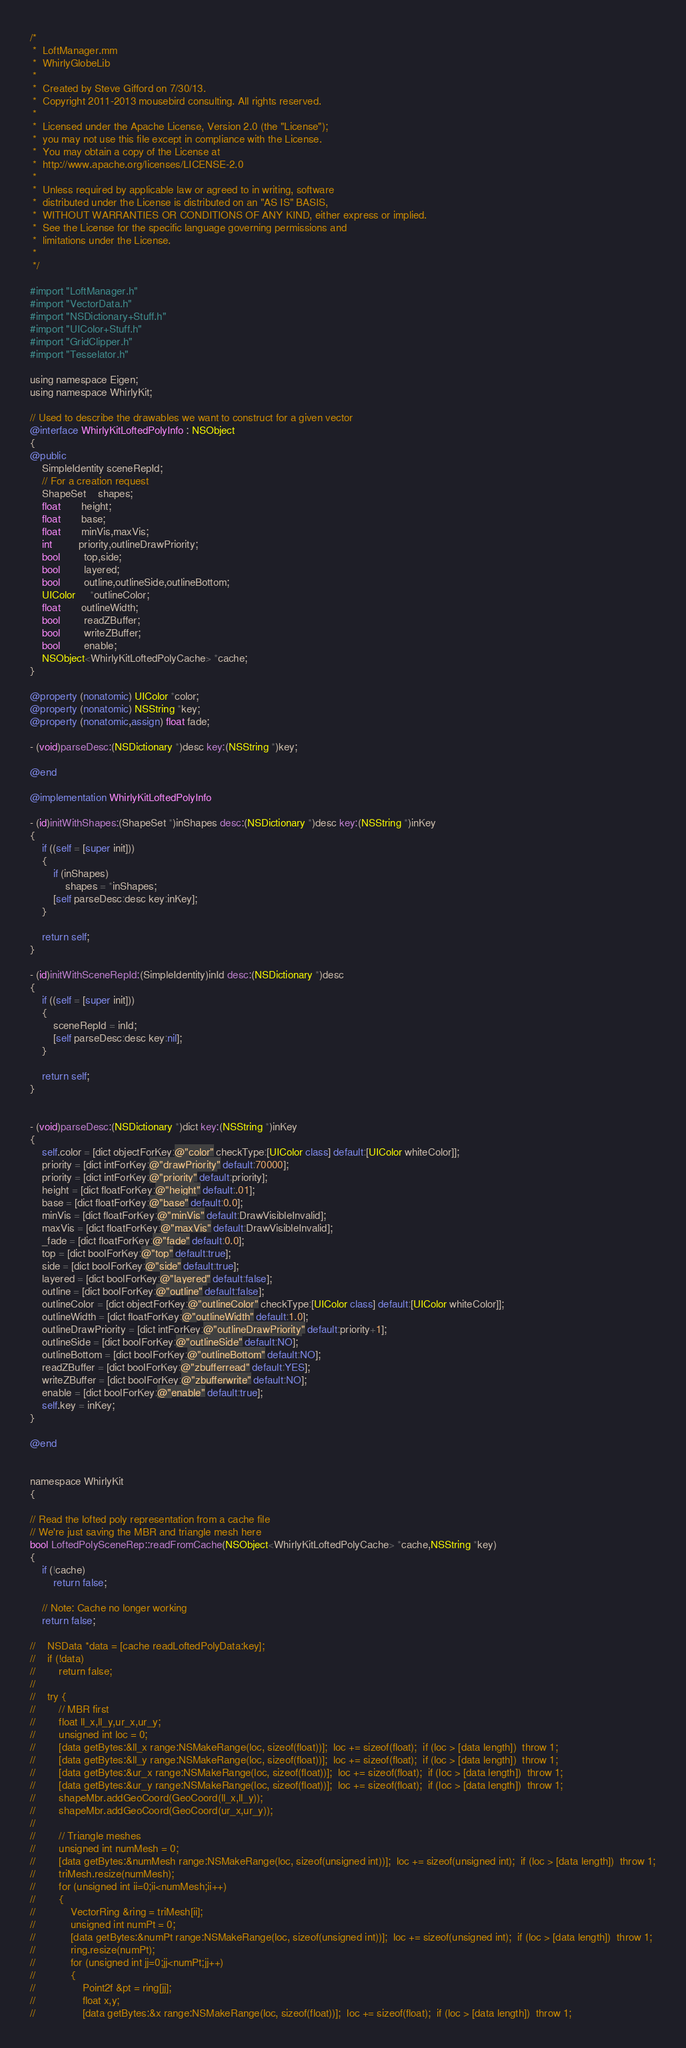Convert code to text. <code><loc_0><loc_0><loc_500><loc_500><_ObjectiveC_>/*
 *  LoftManager.mm
 *  WhirlyGlobeLib
 *
 *  Created by Steve Gifford on 7/30/13.
 *  Copyright 2011-2013 mousebird consulting. All rights reserved.
 *
 *  Licensed under the Apache License, Version 2.0 (the "License");
 *  you may not use this file except in compliance with the License.
 *  You may obtain a copy of the License at
 *  http://www.apache.org/licenses/LICENSE-2.0
 *
 *  Unless required by applicable law or agreed to in writing, software
 *  distributed under the License is distributed on an "AS IS" BASIS,
 *  WITHOUT WARRANTIES OR CONDITIONS OF ANY KIND, either express or implied.
 *  See the License for the specific language governing permissions and
 *  limitations under the License.
 *
 */

#import "LoftManager.h"
#import "VectorData.h"
#import "NSDictionary+Stuff.h"
#import "UIColor+Stuff.h"
#import "GridClipper.h"
#import "Tesselator.h"

using namespace Eigen;
using namespace WhirlyKit;

// Used to describe the drawables we want to construct for a given vector
@interface WhirlyKitLoftedPolyInfo : NSObject
{
@public
    SimpleIdentity sceneRepId;
    // For a creation request
    ShapeSet    shapes;
    float       height;
    float       base;
    float       minVis,maxVis;
    int         priority,outlineDrawPriority;
    bool        top,side;
    bool        layered;
    bool        outline,outlineSide,outlineBottom;
    UIColor     *outlineColor;
    float       outlineWidth;
    bool        readZBuffer;
    bool        writeZBuffer;
    bool        enable;
    NSObject<WhirlyKitLoftedPolyCache> *cache;
}

@property (nonatomic) UIColor *color;
@property (nonatomic) NSString *key;
@property (nonatomic,assign) float fade;

- (void)parseDesc:(NSDictionary *)desc key:(NSString *)key;

@end

@implementation WhirlyKitLoftedPolyInfo

- (id)initWithShapes:(ShapeSet *)inShapes desc:(NSDictionary *)desc key:(NSString *)inKey
{
    if ((self = [super init]))
    {
        if (inShapes)
            shapes = *inShapes;
        [self parseDesc:desc key:inKey];
    }
    
    return self;
}

- (id)initWithSceneRepId:(SimpleIdentity)inId desc:(NSDictionary *)desc
{
    if ((self = [super init]))
    {
        sceneRepId = inId;
        [self parseDesc:desc key:nil];
    }
    
    return self;
}


- (void)parseDesc:(NSDictionary *)dict key:(NSString *)inKey
{
    self.color = [dict objectForKey:@"color" checkType:[UIColor class] default:[UIColor whiteColor]];
    priority = [dict intForKey:@"drawPriority" default:70000];
    priority = [dict intForKey:@"priority" default:priority];
    height = [dict floatForKey:@"height" default:.01];
    base = [dict floatForKey:@"base" default:0.0];
    minVis = [dict floatForKey:@"minVis" default:DrawVisibleInvalid];
    maxVis = [dict floatForKey:@"maxVis" default:DrawVisibleInvalid];
    _fade = [dict floatForKey:@"fade" default:0.0];
    top = [dict boolForKey:@"top" default:true];
    side = [dict boolForKey:@"side" default:true];
    layered = [dict boolForKey:@"layered" default:false];
    outline = [dict boolForKey:@"outline" default:false];
    outlineColor = [dict objectForKey:@"outlineColor" checkType:[UIColor class] default:[UIColor whiteColor]];
    outlineWidth = [dict floatForKey:@"outlineWidth" default:1.0];
    outlineDrawPriority = [dict intForKey:@"outlineDrawPriority" default:priority+1];
    outlineSide = [dict boolForKey:@"outlineSide" default:NO];
    outlineBottom = [dict boolForKey:@"outlineBottom" default:NO];
    readZBuffer = [dict boolForKey:@"zbufferread" default:YES];
    writeZBuffer = [dict boolForKey:@"zbufferwrite" default:NO];
    enable = [dict boolForKey:@"enable" default:true];
    self.key = inKey;
}

@end


namespace WhirlyKit
{

// Read the lofted poly representation from a cache file
// We're just saving the MBR and triangle mesh here
bool LoftedPolySceneRep::readFromCache(NSObject<WhirlyKitLoftedPolyCache> *cache,NSString *key)
{
    if (!cache)
        return false;
    
    // Note: Cache no longer working
    return false;
    
//    NSData *data = [cache readLoftedPolyData:key];
//    if (!data)
//        return false;
//    
//    try {
//        // MBR first
//        float ll_x,ll_y,ur_x,ur_y;
//        unsigned int loc = 0;
//        [data getBytes:&ll_x range:NSMakeRange(loc, sizeof(float))];  loc += sizeof(float);  if (loc > [data length])  throw 1;
//        [data getBytes:&ll_y range:NSMakeRange(loc, sizeof(float))];  loc += sizeof(float);  if (loc > [data length])  throw 1;
//        [data getBytes:&ur_x range:NSMakeRange(loc, sizeof(float))];  loc += sizeof(float);  if (loc > [data length])  throw 1;
//        [data getBytes:&ur_y range:NSMakeRange(loc, sizeof(float))];  loc += sizeof(float);  if (loc > [data length])  throw 1;
//        shapeMbr.addGeoCoord(GeoCoord(ll_x,ll_y));
//        shapeMbr.addGeoCoord(GeoCoord(ur_x,ur_y));
//        
//        // Triangle meshes
//        unsigned int numMesh = 0;
//        [data getBytes:&numMesh range:NSMakeRange(loc, sizeof(unsigned int))];  loc += sizeof(unsigned int);  if (loc > [data length])  throw 1;
//        triMesh.resize(numMesh);
//        for (unsigned int ii=0;ii<numMesh;ii++)
//        {
//            VectorRing &ring = triMesh[ii];
//            unsigned int numPt = 0;
//            [data getBytes:&numPt range:NSMakeRange(loc, sizeof(unsigned int))];  loc += sizeof(unsigned int);  if (loc > [data length])  throw 1;
//            ring.resize(numPt);
//            for (unsigned int jj=0;jj<numPt;jj++)
//            {
//                Point2f &pt = ring[jj];
//                float x,y;
//                [data getBytes:&x range:NSMakeRange(loc, sizeof(float))];  loc += sizeof(float);  if (loc > [data length])  throw 1;</code> 